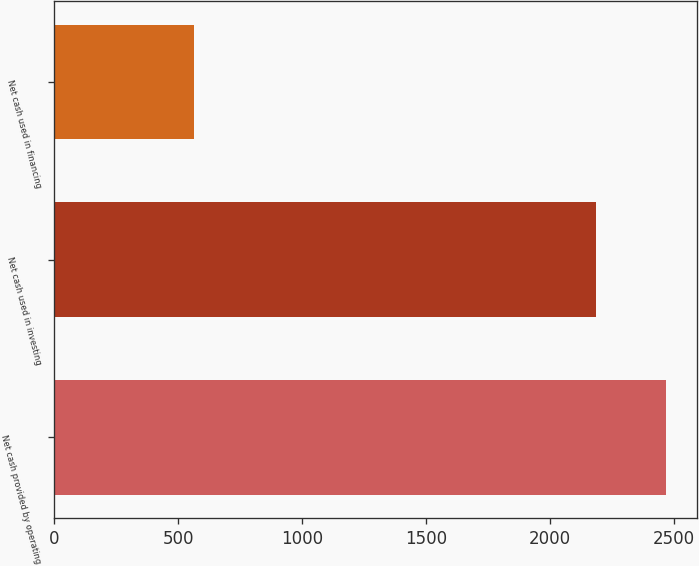Convert chart. <chart><loc_0><loc_0><loc_500><loc_500><bar_chart><fcel>Net cash provided by operating<fcel>Net cash used in investing<fcel>Net cash used in financing<nl><fcel>2469<fcel>2185<fcel>566<nl></chart> 